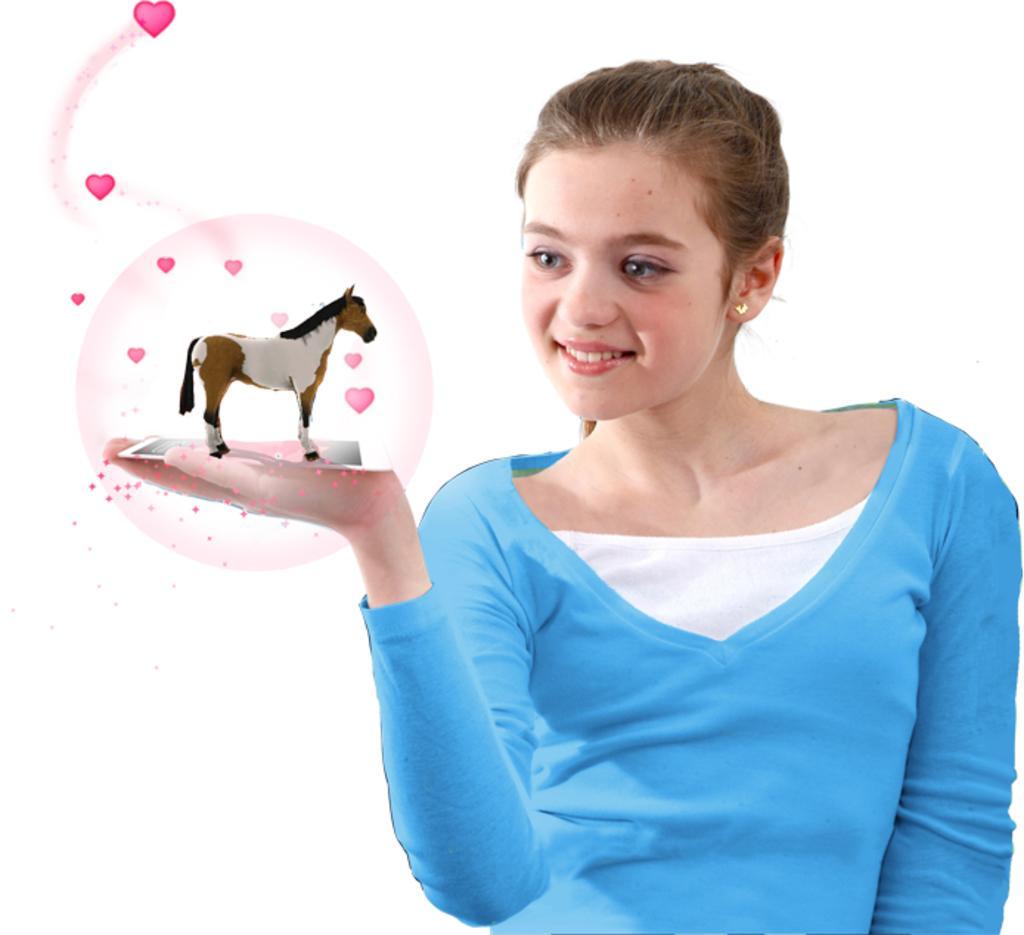In one or two sentences, can you explain what this image depicts? In this I can see a girl holding a horse toy in her hand and I can see smile on her face and a white color background. 